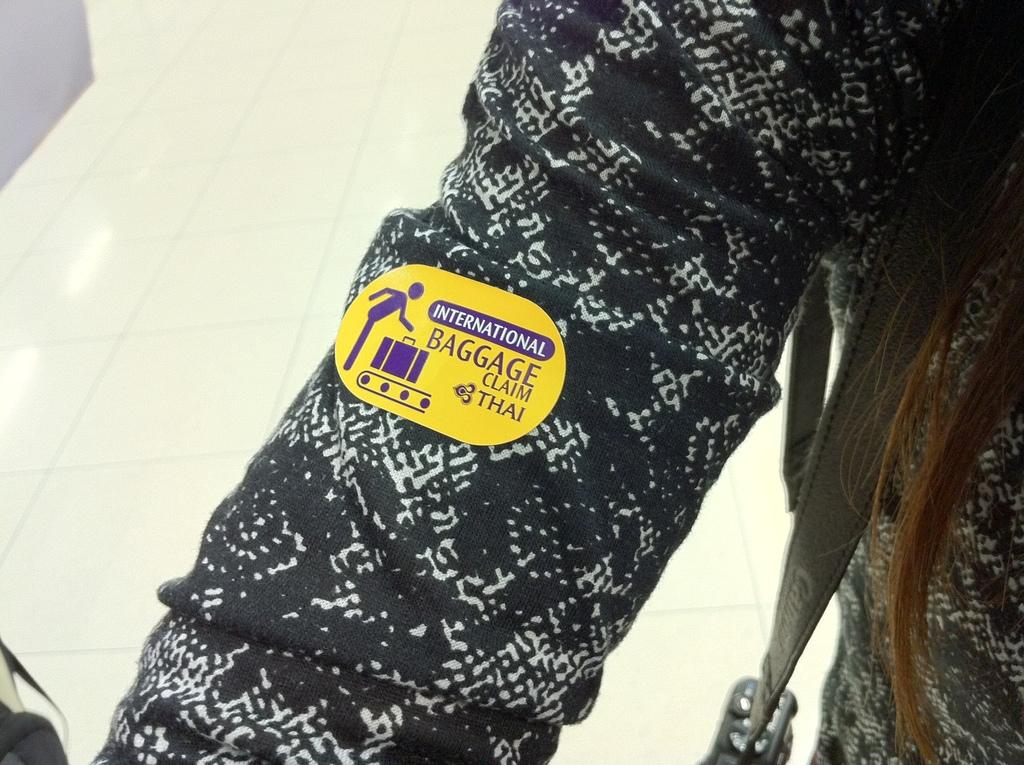What is on the person's hand in the foreground of the image? There is a sticker on the person's hand in the foreground of the image. What is the person wearing in the image? The person is wearing a bag. What can be seen in the background of the image? The background of the image includes the floor. How much wealth does the owl in the image possess? There is no owl present in the image, so it is not possible to determine the wealth of an owl. 